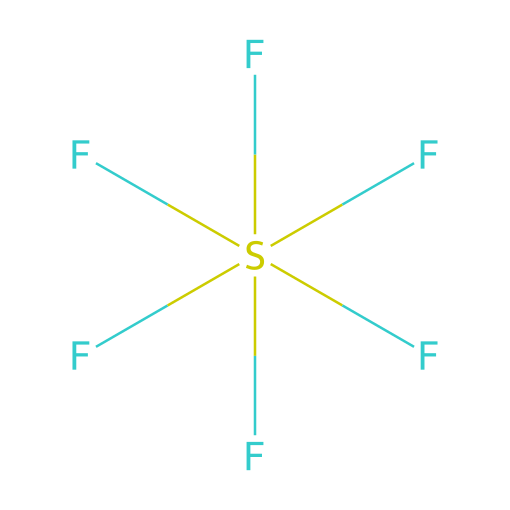What is the main component of this chemical? The chemical structure depicts sulfur attached to six fluorine atoms. This indicates that the main component is sulfur hexafluoride.
Answer: sulfur hexafluoride How many fluorine atoms are present in this compound? By examining the structure, we can see six fluorine atoms bonded to a single sulfur atom, so the count is six.
Answer: six What type of bonding is present in sulfur hexafluoride? The fluorine atoms are covalently bonded to the sulfur atom. Given the arrangement and number of bonds, it indicates multiple single covalent bonds.
Answer: covalent Is sulfur hexafluoride a hypervalent compound? A hypervalent compound is one that has more than eight electrons around its central atom. Since sulfur here has twelve electrons (six from bonds with fluorine), it qualifies as hypervalent.
Answer: yes What is the hybridization of sulfur in sulfur hexafluoride? In sulfur hexafluoride, sulfur exhibits sp³d² hybridization, which accommodates six bonding pairs, indicating a central position with octahedral geometry.
Answer: sp³d² 